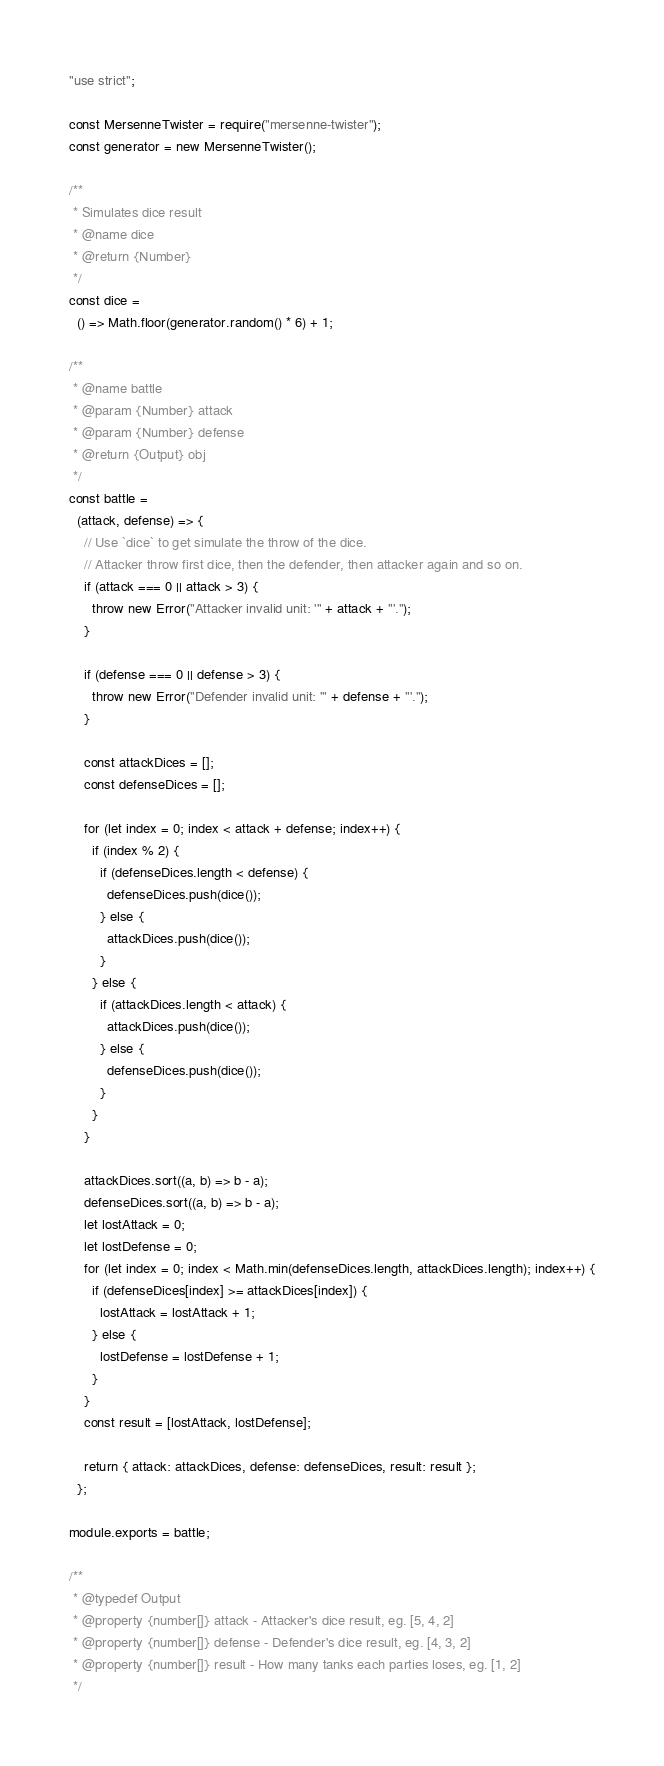<code> <loc_0><loc_0><loc_500><loc_500><_JavaScript_>"use strict";

const MersenneTwister = require("mersenne-twister");
const generator = new MersenneTwister();

/**
 * Simulates dice result
 * @name dice
 * @return {Number}
 */
const dice =
  () => Math.floor(generator.random() * 6) + 1;

/**
 * @name battle
 * @param {Number} attack
 * @param {Number} defense
 * @return {Output} obj
 */
const battle =
  (attack, defense) => {
    // Use `dice` to get simulate the throw of the dice.
    // Attacker throw first dice, then the defender, then attacker again and so on.
    if (attack === 0 || attack > 3) {
      throw new Error("Attacker invalid unit: '" + attack + "'.");
    }

    if (defense === 0 || defense > 3) {
      throw new Error("Defender invalid unit: '" + defense + "'.");
    }

    const attackDices = [];
    const defenseDices = [];

    for (let index = 0; index < attack + defense; index++) {
      if (index % 2) {
        if (defenseDices.length < defense) {
          defenseDices.push(dice());
        } else {
          attackDices.push(dice());
        }
      } else {
        if (attackDices.length < attack) {
          attackDices.push(dice());
        } else {
          defenseDices.push(dice());
        }
      }
    }

    attackDices.sort((a, b) => b - a);
    defenseDices.sort((a, b) => b - a);
    let lostAttack = 0;
    let lostDefense = 0;
    for (let index = 0; index < Math.min(defenseDices.length, attackDices.length); index++) {
      if (defenseDices[index] >= attackDices[index]) {
        lostAttack = lostAttack + 1;
      } else {
        lostDefense = lostDefense + 1;
      }
    }
    const result = [lostAttack, lostDefense];

    return { attack: attackDices, defense: defenseDices, result: result };
  };

module.exports = battle;

/**
 * @typedef Output
 * @property {number[]} attack - Attacker's dice result, eg. [5, 4, 2]
 * @property {number[]} defense - Defender's dice result, eg. [4, 3, 2]
 * @property {number[]} result - How many tanks each parties loses, eg. [1, 2]
 */
</code> 